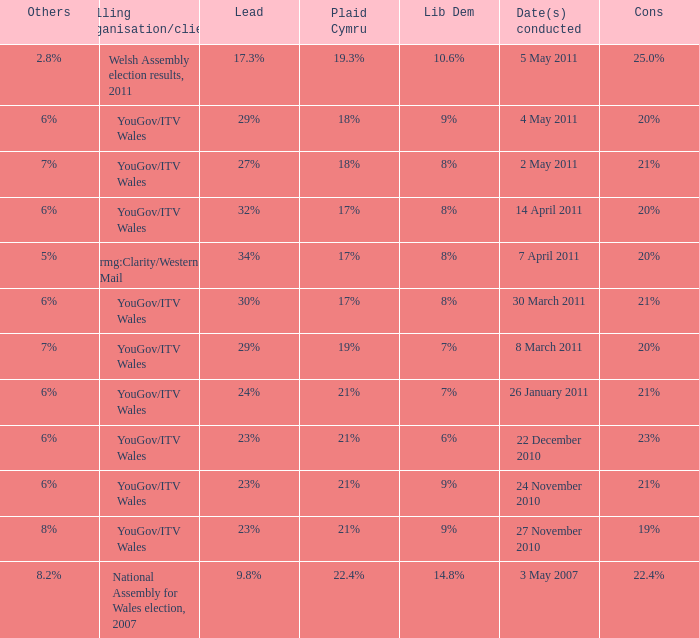Tell me the dates conducted for plaid cymru of 19% 8 March 2011. 